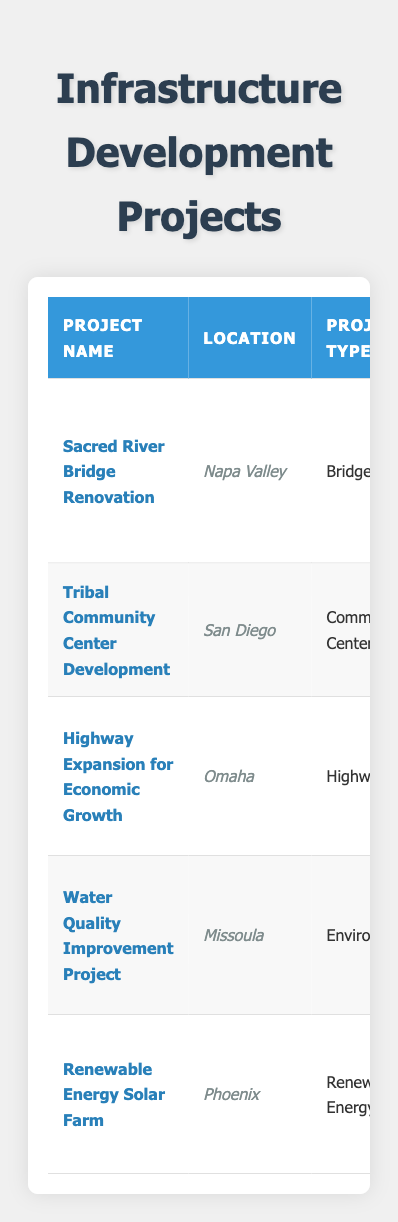What is the project name with the highest budget? Inspecting the budgets listed for each project, the highest value is $5,000,000, which corresponds to the "Highway Expansion for Economic Growth" project.
Answer: Highway Expansion for Economic Growth How many projects are located in California? The projects listed in the table for California are "Sacred River Bridge Renovation" and "Tribal Community Center Development," totaling 2 projects.
Answer: 2 What is the total budget of all projects? By adding the budgets together: $1,500,000 + $750,000 + $5,000,000 + $300,000 + $2,000,000 = $9,550,000.
Answer: $9,550,000 Which project benefits the Salish and Kootenai Tribes? Reviewing the community impacted section, the project specifically listed as benefiting the Salish and Kootenai Tribes is the "Water Quality Improvement Project."
Answer: Water Quality Improvement Project What is the completion date of the project with the least budget? The least budgeted project is the "Water Quality Improvement Project" with a budget of $300,000, and its completion date is July 19, 2023.
Answer: July 19, 2023 Are there more environmental projects than community center projects? There is 1 environmental project ("Water Quality Improvement Project") and 1 community center project ("Tribal Community Center Development"), making them equal.
Answer: No What is the average budget of all the projects? To find the average, sum all budgets: $1,500,000 + $750,000 + $5,000,000 + $300,000 + $2,000,000 = $9,550,000, then divide by 5 (number of projects), giving $1,910,000.
Answer: $1,910,000 Which two funding sources are common in the projects? Reviewing the funding sources, "Tribal" is mentioned in several projects: "Tribal Infrastructure Fund," "Tribal Council Funding," and "Tribal Renewable Energy Fund," indicating a common theme in tribal funding.
Answer: Tribal funding is common Which project's benefit emphasizes access to local businesses? The "Sacred River Bridge Renovation" project emphasizes improved access to both tribal lands and local businesses based on its benefit description.
Answer: Sacred River Bridge Renovation How many projects are scheduled to be completed in 2024? The projects set for completion in 2024 are "Highway Expansion for Economic Growth" and "Renewable Energy Solar Farm," totaling 2 projects.
Answer: 2 What is the latest start date among all projects? Comparing the start dates, "Highway Expansion for Economic Growth" has the latest start date of January 1, 2023.
Answer: January 1, 2023 